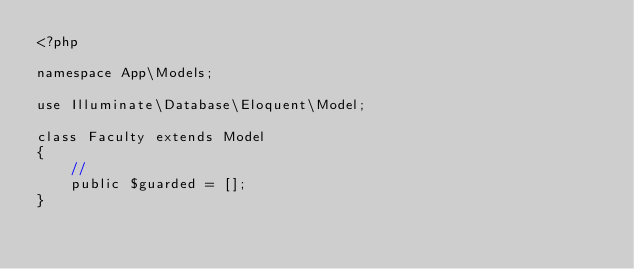Convert code to text. <code><loc_0><loc_0><loc_500><loc_500><_PHP_><?php

namespace App\Models;

use Illuminate\Database\Eloquent\Model;

class Faculty extends Model
{
    //
    public $guarded = [];
}
</code> 